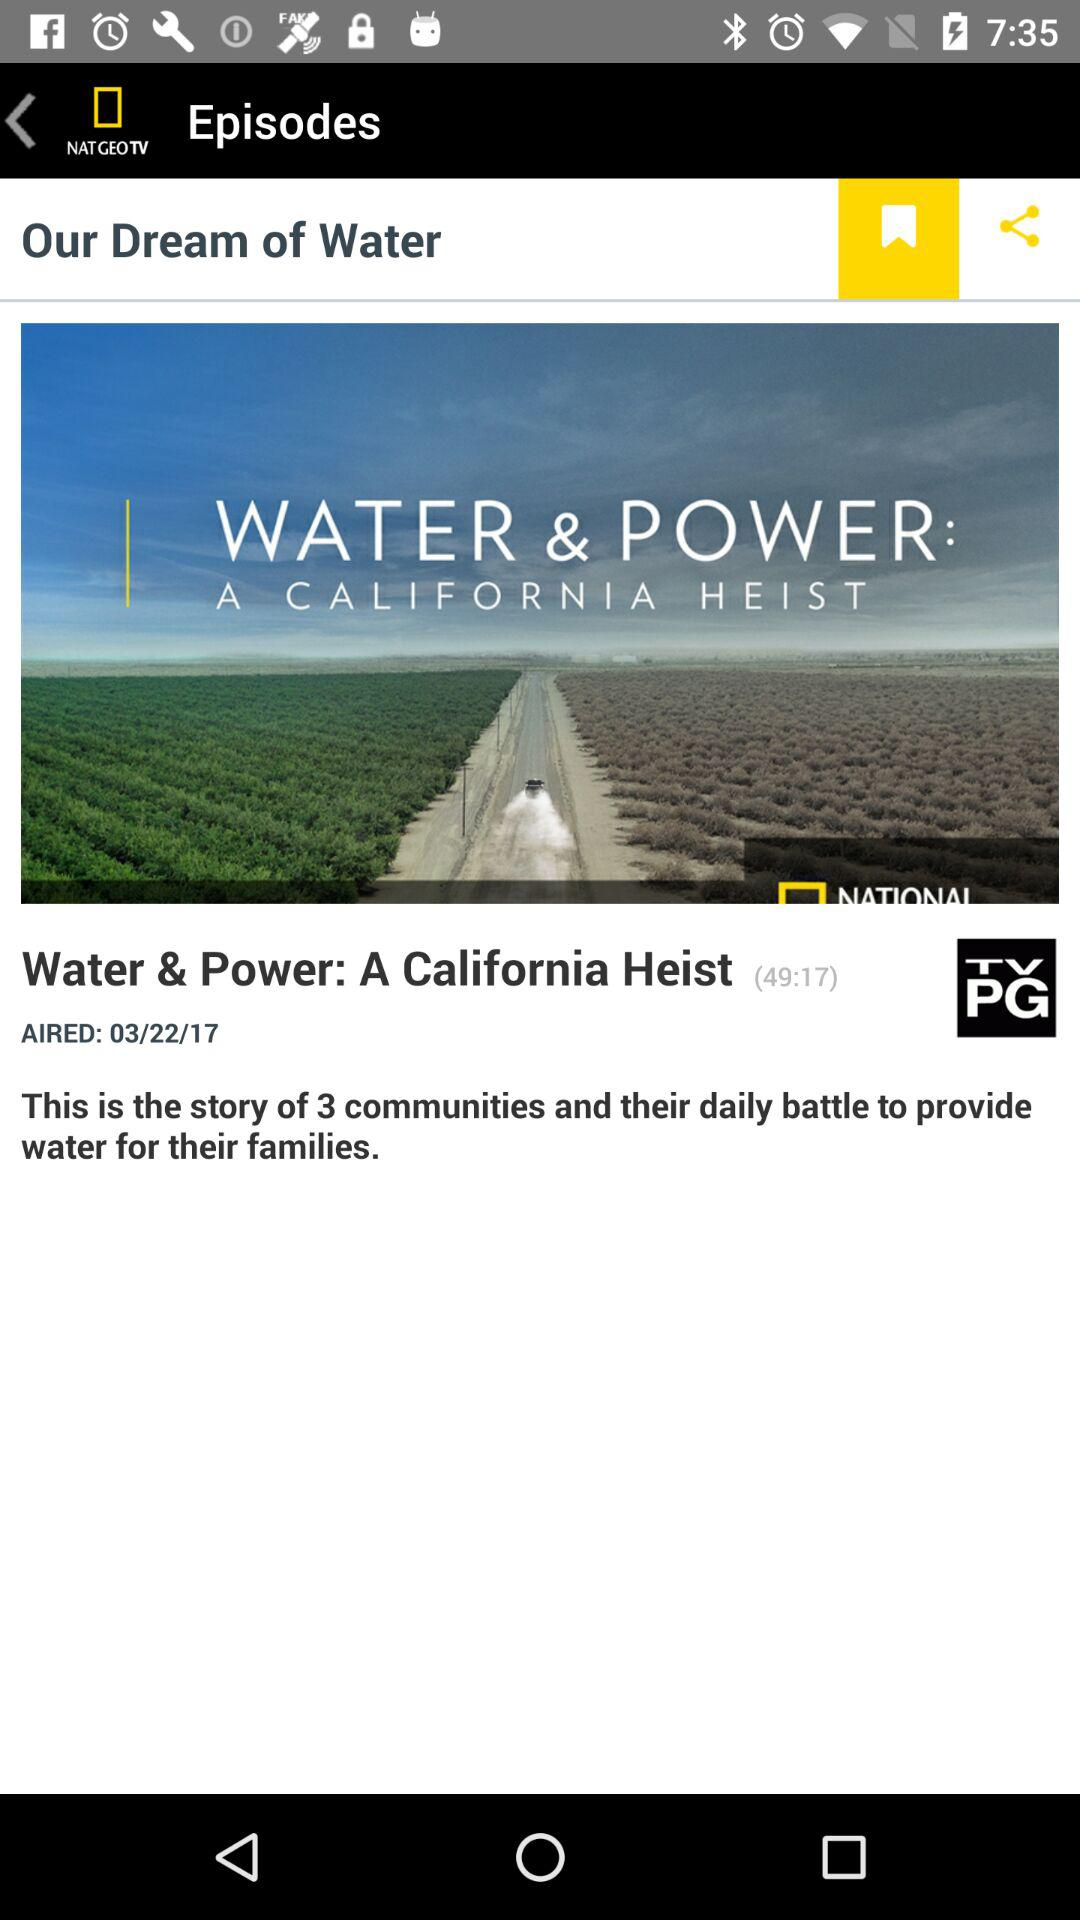How many communities are mentioned in the episode?
Answer the question using a single word or phrase. 3 